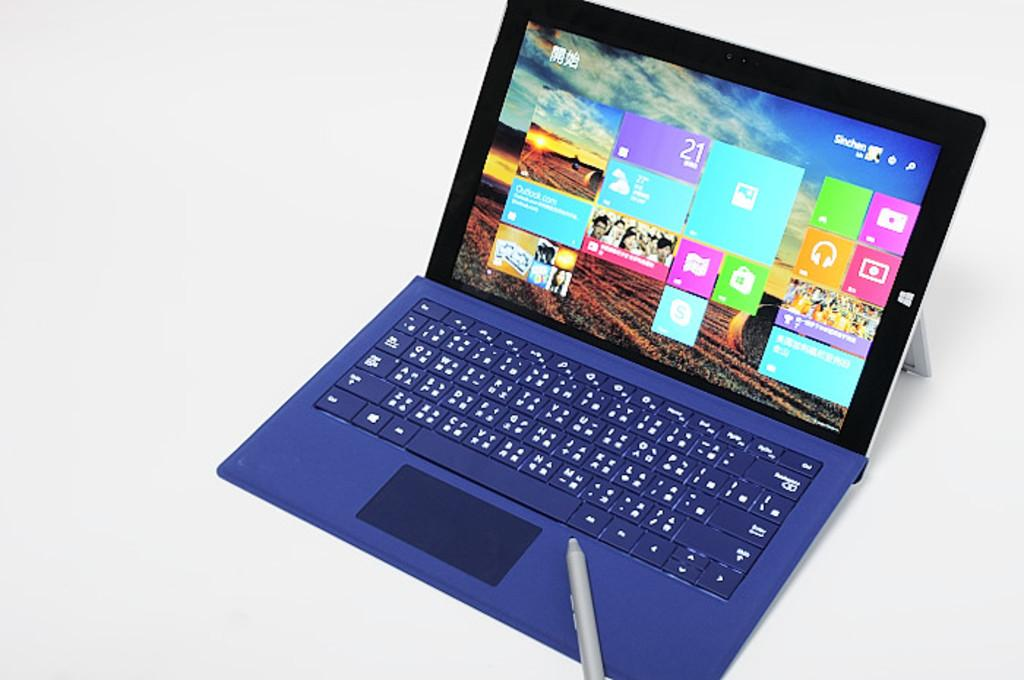What electronic device is visible in the image? There is a laptop in the image. Is there anything placed on top of the laptop? Yes, there is a marker placed on top of the laptop. What type of bulb is used to illuminate the laptop screen in the image? There is no information about the type of bulb used to illuminate the laptop screen in the image. Additionally, the image does not show any bulbs. 